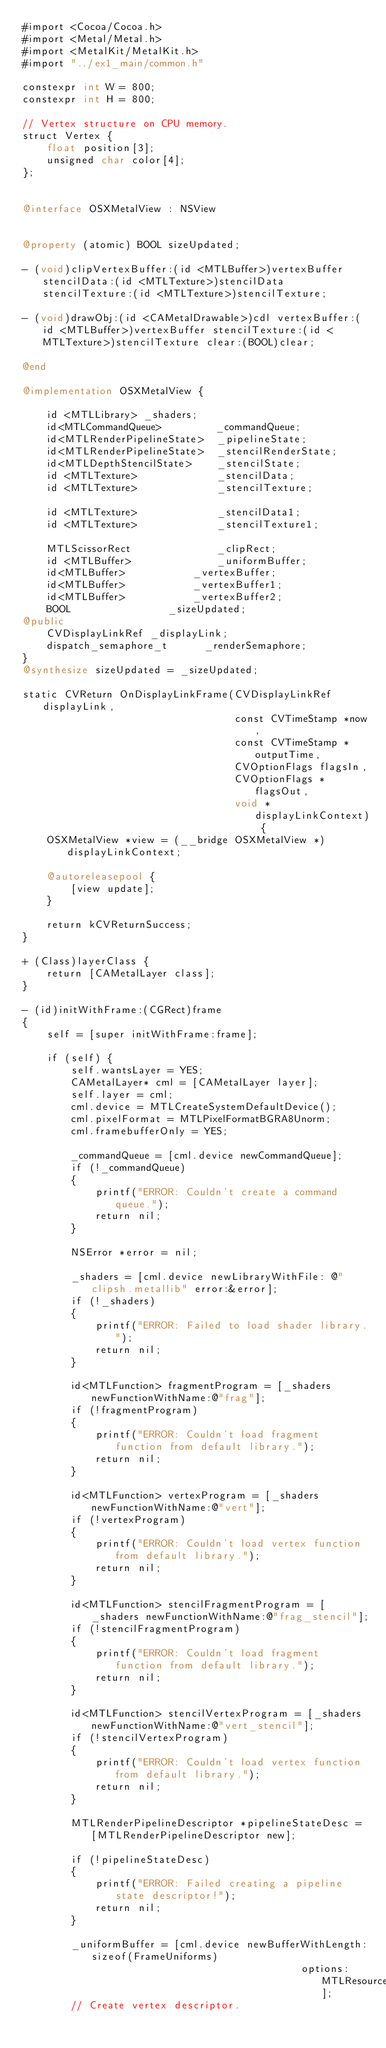Convert code to text. <code><loc_0><loc_0><loc_500><loc_500><_ObjectiveC_>#import <Cocoa/Cocoa.h>
#import <Metal/Metal.h>
#import <MetalKit/MetalKit.h>
#import "../ex1_main/common.h"

constexpr int W = 800;
constexpr int H = 800;

// Vertex structure on CPU memory.
struct Vertex {
    float position[3];
    unsigned char color[4];
};


@interface OSXMetalView : NSView


@property (atomic) BOOL sizeUpdated;

- (void)clipVertexBuffer:(id <MTLBuffer>)vertexBuffer stencilData:(id <MTLTexture>)stencilData stencilTexture:(id <MTLTexture>)stencilTexture;

- (void)drawObj:(id <CAMetalDrawable>)cdl vertexBuffer:(id <MTLBuffer>)vertexBuffer stencilTexture:(id <MTLTexture>)stencilTexture clear:(BOOL)clear;

@end

@implementation OSXMetalView {

    id <MTLLibrary> _shaders;
    id<MTLCommandQueue>         _commandQueue;
    id<MTLRenderPipelineState>  _pipelineState;
    id<MTLRenderPipelineState>  _stencilRenderState;
    id<MTLDepthStencilState>    _stencilState;
    id <MTLTexture>             _stencilData;
    id <MTLTexture>             _stencilTexture;

    id <MTLTexture>             _stencilData1;
    id <MTLTexture>             _stencilTexture1;

    MTLScissorRect              _clipRect;
    id <MTLBuffer>              _uniformBuffer;
    id<MTLBuffer>  			    _vertexBuffer;
    id<MTLBuffer>  			    _vertexBuffer1;
    id<MTLBuffer>  			    _vertexBuffer2;
    BOOL 				        _sizeUpdated;
@public
    CVDisplayLinkRef _displayLink;
    dispatch_semaphore_t 	    _renderSemaphore;
}
@synthesize sizeUpdated = _sizeUpdated;

static CVReturn OnDisplayLinkFrame(CVDisplayLinkRef displayLink,
                                   const CVTimeStamp *now,
                                   const CVTimeStamp *outputTime,
                                   CVOptionFlags flagsIn,
                                   CVOptionFlags *flagsOut,
                                   void *displayLinkContext) {
    OSXMetalView *view = (__bridge OSXMetalView *) displayLinkContext;

    @autoreleasepool {
        [view update];
    }

    return kCVReturnSuccess;
}

+ (Class)layerClass {
    return [CAMetalLayer class];
}

- (id)initWithFrame:(CGRect)frame
{
    self = [super initWithFrame:frame];

    if (self) {
        self.wantsLayer = YES;
        CAMetalLayer* cml = [CAMetalLayer layer];
        self.layer = cml;
        cml.device = MTLCreateSystemDefaultDevice();
        cml.pixelFormat = MTLPixelFormatBGRA8Unorm;
        cml.framebufferOnly = YES;

        _commandQueue = [cml.device newCommandQueue];
        if (!_commandQueue)
        {
            printf("ERROR: Couldn't create a command queue.");
            return nil;
        }

        NSError *error = nil;

        _shaders = [cml.device newLibraryWithFile: @"clipsh.metallib" error:&error];
        if (!_shaders)
        {
            printf("ERROR: Failed to load shader library.");
            return nil;
        }

        id<MTLFunction> fragmentProgram = [_shaders newFunctionWithName:@"frag"];
        if (!fragmentProgram)
        {
            printf("ERROR: Couldn't load fragment function from default library.");
            return nil;
        }

        id<MTLFunction> vertexProgram = [_shaders newFunctionWithName:@"vert"];
        if (!vertexProgram)
        {
            printf("ERROR: Couldn't load vertex function from default library.");
            return nil;
        }

        id<MTLFunction> stencilFragmentProgram = [_shaders newFunctionWithName:@"frag_stencil"];
        if (!stencilFragmentProgram)
        {
            printf("ERROR: Couldn't load fragment function from default library.");
            return nil;
        }

        id<MTLFunction> stencilVertexProgram = [_shaders newFunctionWithName:@"vert_stencil"];
        if (!stencilVertexProgram)
        {
            printf("ERROR: Couldn't load vertex function from default library.");
            return nil;
        }

        MTLRenderPipelineDescriptor *pipelineStateDesc = [MTLRenderPipelineDescriptor new];

        if (!pipelineStateDesc)
        {
            printf("ERROR: Failed creating a pipeline state descriptor!");
            return nil;
        }

        _uniformBuffer = [cml.device newBufferWithLength:sizeof(FrameUniforms)
                                              options:MTLResourceCPUCacheModeWriteCombined];
        // Create vertex descriptor.</code> 